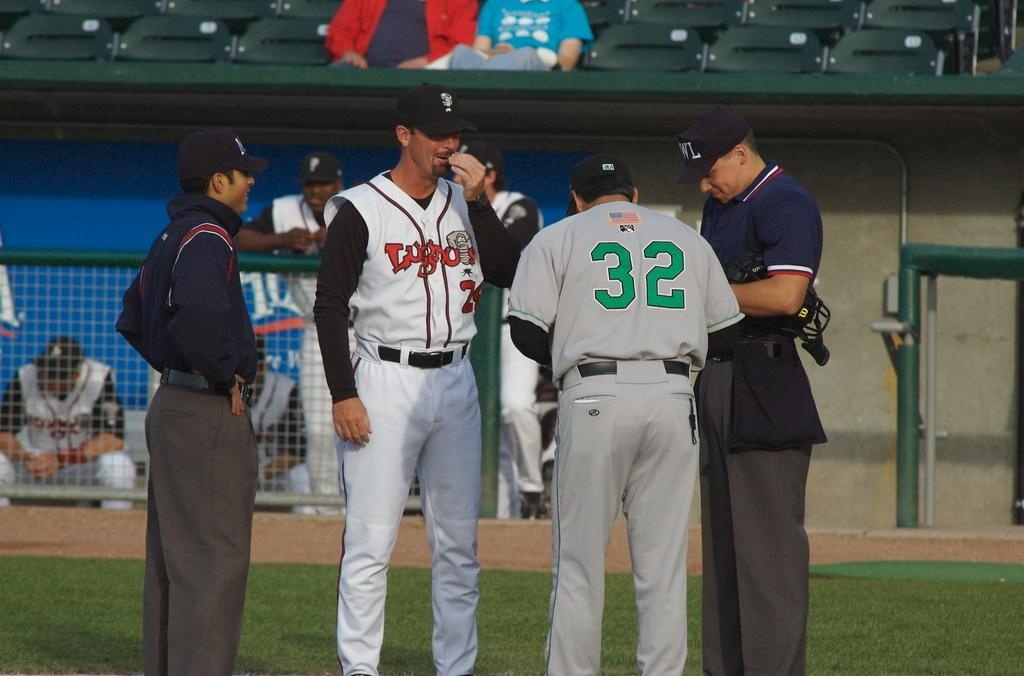<image>
Render a clear and concise summary of the photo. Player number 32 consults with the umpires on the field. 